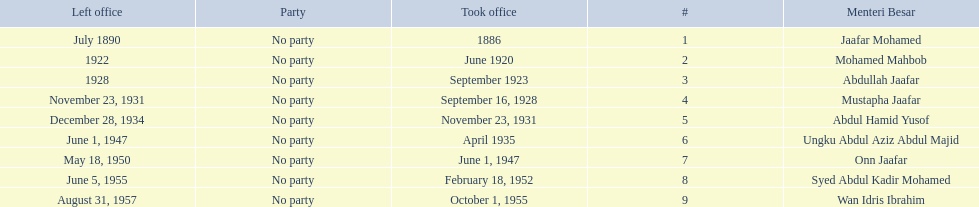What is the number of menteri besar that served 4 or more years? 3. 